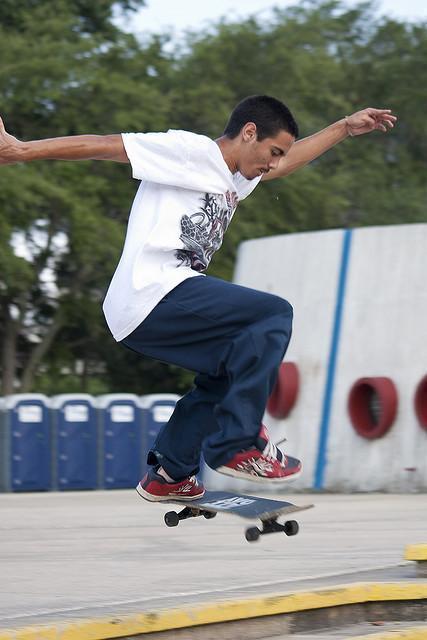How many umbrellas with yellow stripes are on the beach?
Give a very brief answer. 0. 